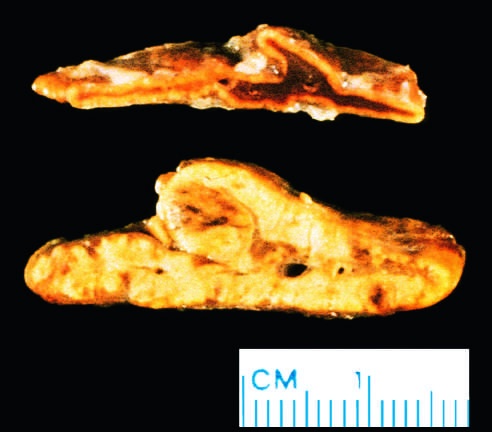what was the abnormal gland from?
Answer the question using a single word or phrase. A patient with acth-dependent cushing syndrome 